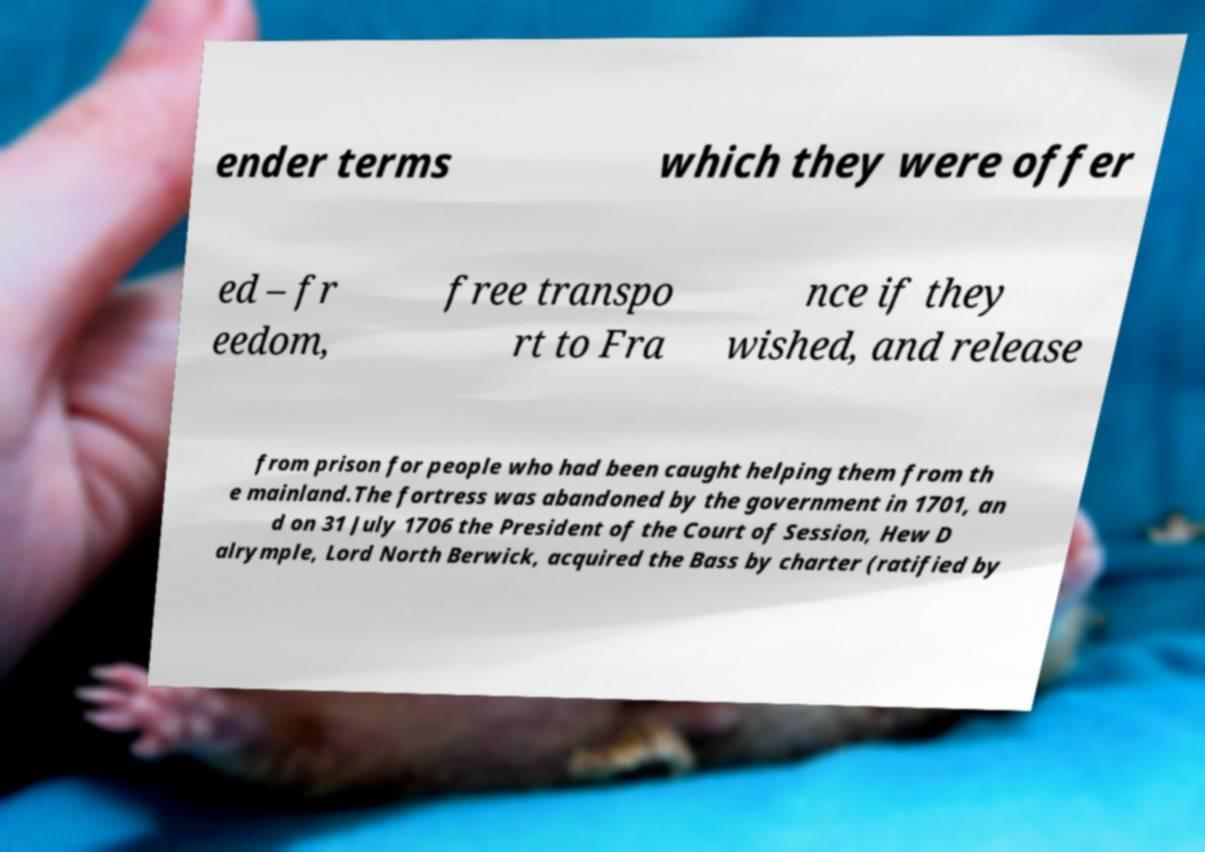For documentation purposes, I need the text within this image transcribed. Could you provide that? ender terms which they were offer ed – fr eedom, free transpo rt to Fra nce if they wished, and release from prison for people who had been caught helping them from th e mainland.The fortress was abandoned by the government in 1701, an d on 31 July 1706 the President of the Court of Session, Hew D alrymple, Lord North Berwick, acquired the Bass by charter (ratified by 